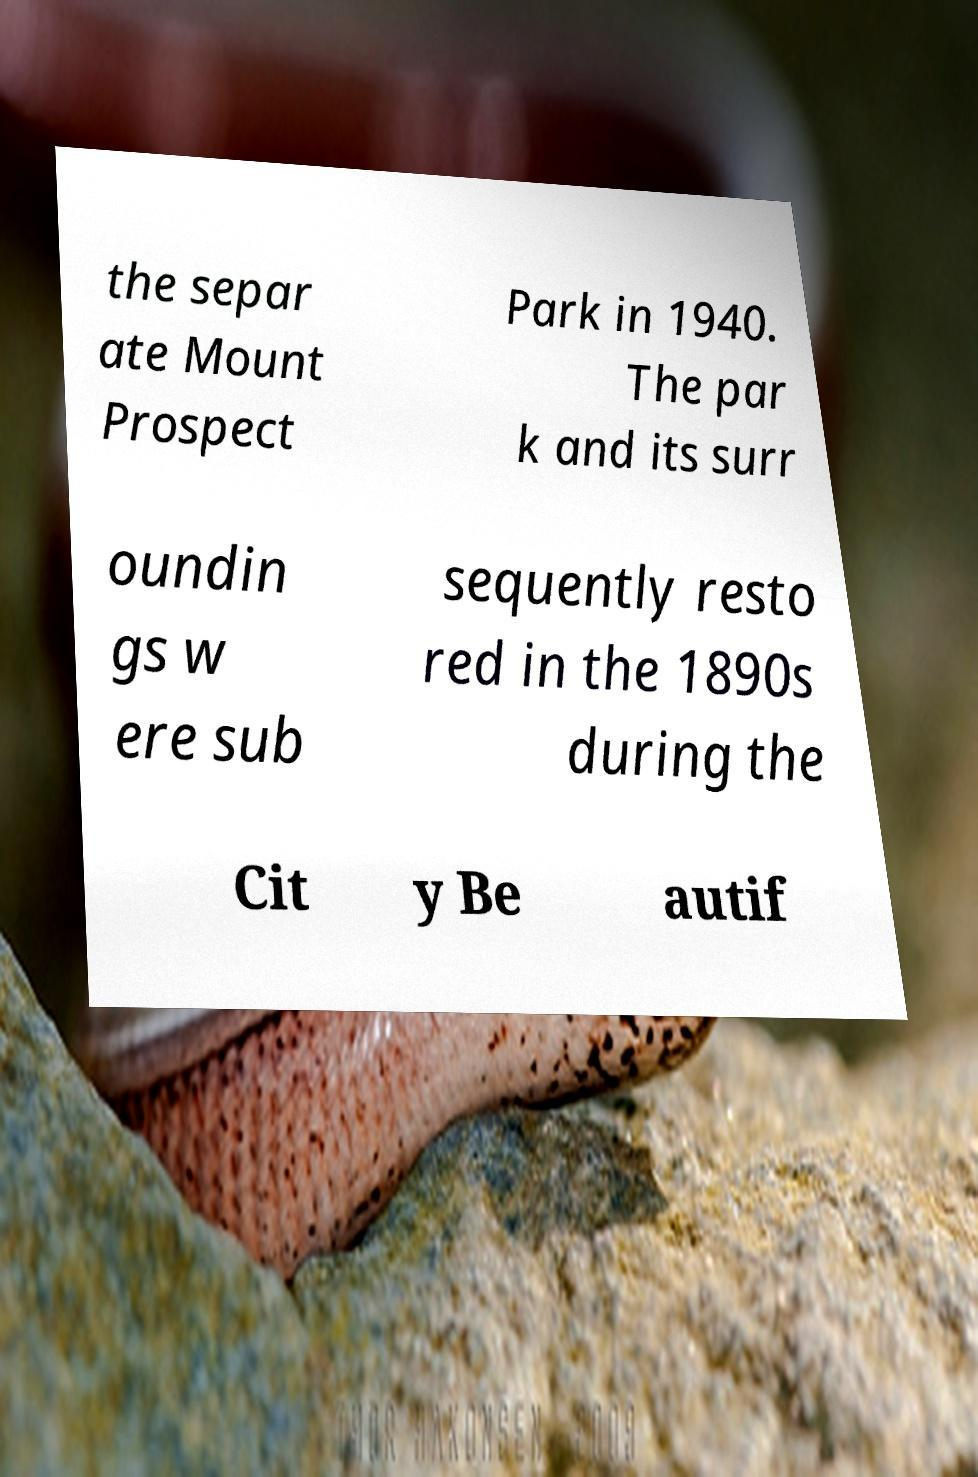What messages or text are displayed in this image? I need them in a readable, typed format. the separ ate Mount Prospect Park in 1940. The par k and its surr oundin gs w ere sub sequently resto red in the 1890s during the Cit y Be autif 